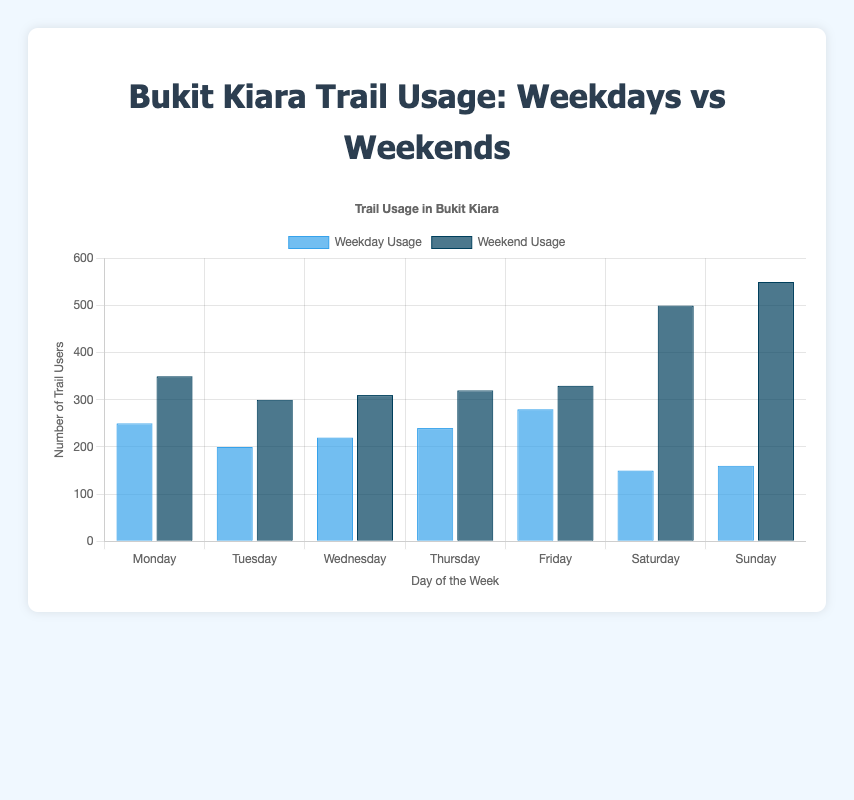Which day has the highest average trail usage? To find the average usage for each day, we add the weekday and weekend values and then divide by 2. The calculations are as follows:
- Monday: (250 + 350) / 2 = 300
- Tuesday: (200 + 300) / 2 = 250
- Wednesday: (220 + 310) / 2 = 265
- Thursday: (240 + 320) / 2 = 280
- Friday: (280 + 330) / 2 = 305
- Saturday: (150 + 500) / 2 = 325
- Sunday: (160 + 550) / 2 = 355
The highest average is on Sunday.
Answer: Sunday Which day has the lowest weekday trail usage? Examining only the weekday usage values, the numbers are:
- Monday: 250
- Tuesday: 200
- Wednesday: 220
- Thursday: 240
- Friday: 280
- Saturday: 150
- Sunday: 160
The lowest usage is on Saturday.
Answer: Saturday How much greater is the trail usage on Sunday compared to Saturday? To determine the difference, subtract Saturday's usage from Sunday's usage:
- Weekend: 550 - 500 = 50
- Weekday: 160 - 150 = 10
Adding the differences: 50 (weekend) + 10 (weekday) = 60
Answer: 60 On which days is the trail usage higher on weekends compared to weekdays? Compare the weekend and weekday usage for each day:
- Monday: 350 vs 250 (Weekend > Weekday)
- Tuesday: 300 vs 200 (Weekend > Weekday)
- Wednesday: 310 vs 220 (Weekend > Weekday)
- Thursday: 320 vs 240 (Weekend > Weekday)
- Friday: 330 vs 280 (Weekend > Weekday)
- Saturday: 500 vs 150 (Weekend > Weekday)
- Sunday: 550 vs 160 (Weekend > Weekday)
The trail usage is higher on weekends for all days.
Answer: All days What is the total trail usage for the entire week? Summing the weekday and weekend values across all days:
- Weekdays: 250 + 200 + 220 + 240 + 280 + 150 + 160 = 1500
- Weekends: 350 + 300 + 310 + 320 + 330 + 500 + 550 = 2660
Adding them together: 1500 + 2660 = 4160
Answer: 4160 